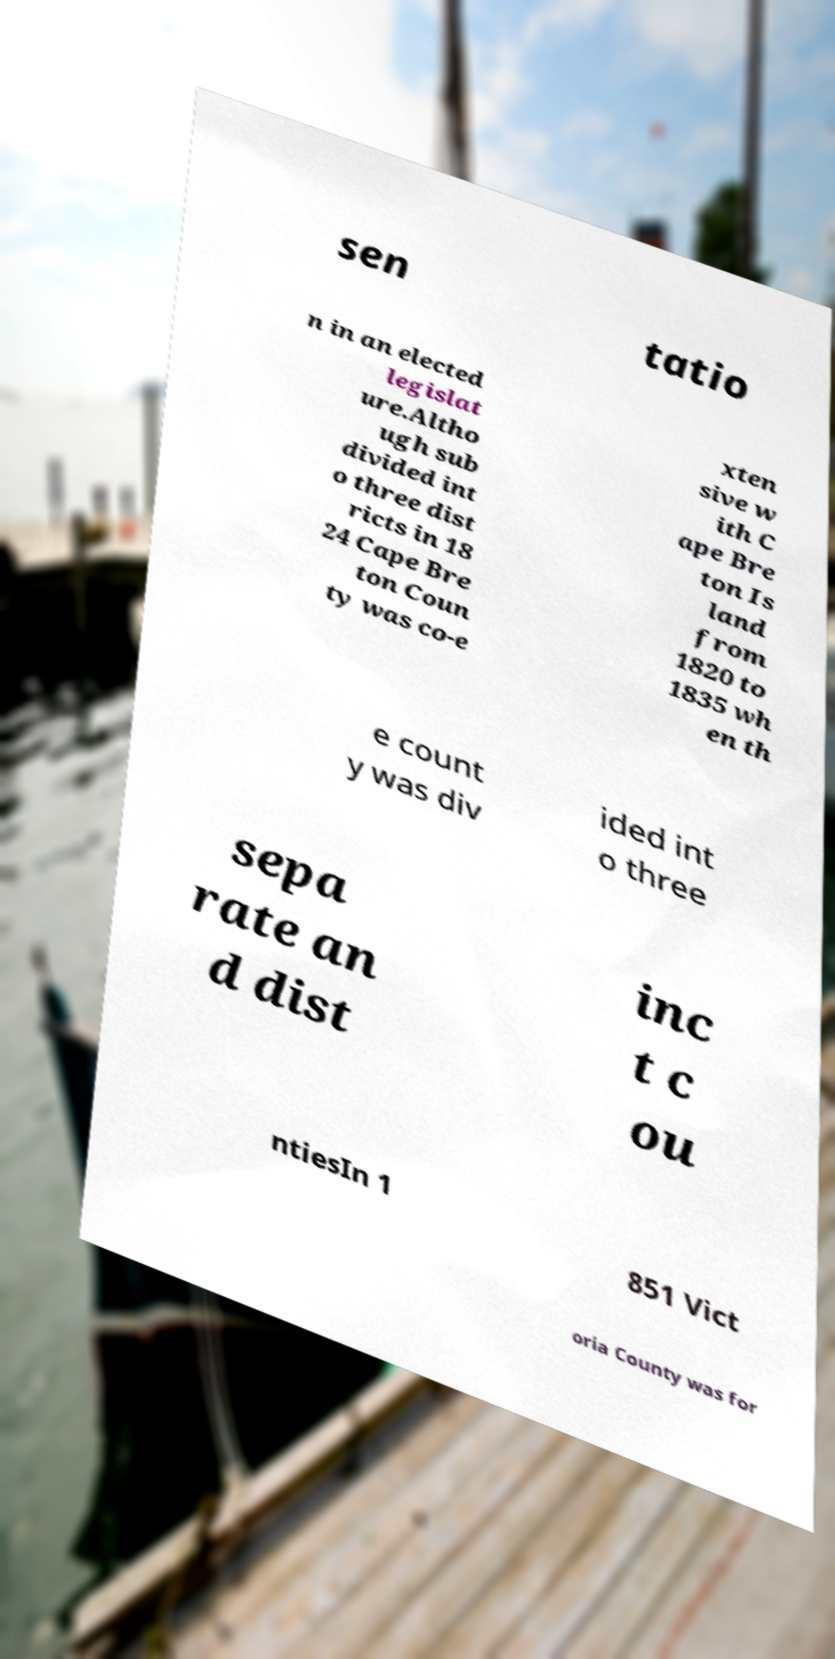I need the written content from this picture converted into text. Can you do that? sen tatio n in an elected legislat ure.Altho ugh sub divided int o three dist ricts in 18 24 Cape Bre ton Coun ty was co-e xten sive w ith C ape Bre ton Is land from 1820 to 1835 wh en th e count y was div ided int o three sepa rate an d dist inc t c ou ntiesIn 1 851 Vict oria County was for 